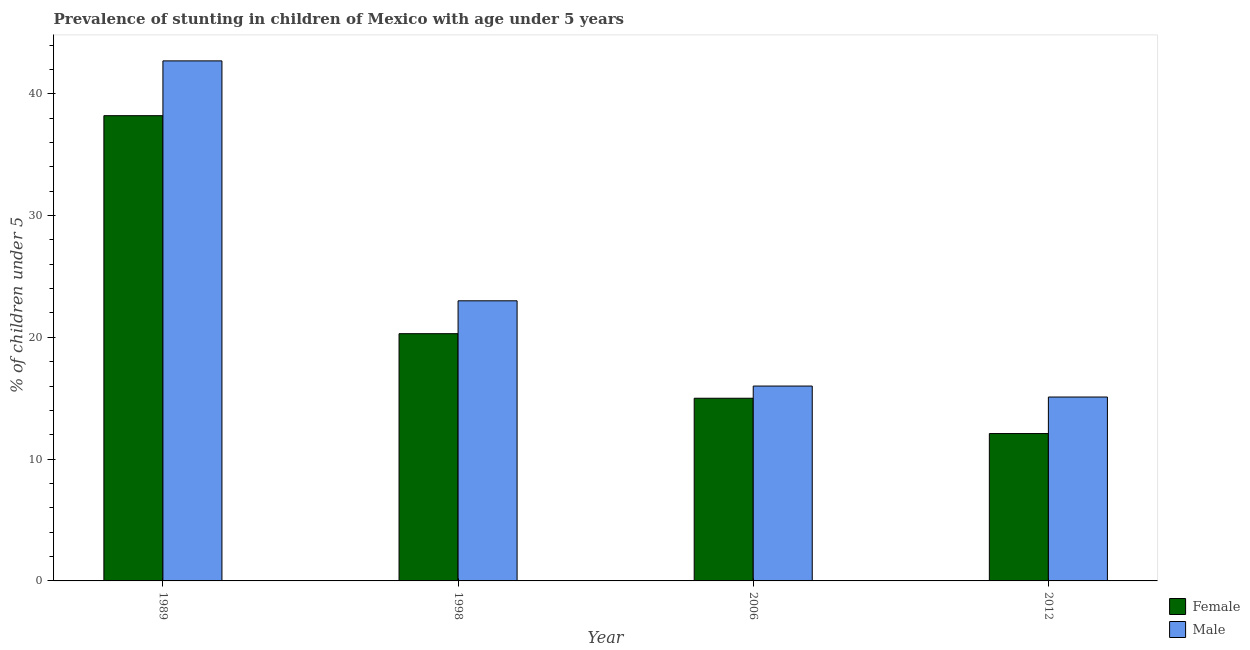How many different coloured bars are there?
Provide a short and direct response. 2. Are the number of bars per tick equal to the number of legend labels?
Keep it short and to the point. Yes. Are the number of bars on each tick of the X-axis equal?
Make the answer very short. Yes. What is the label of the 1st group of bars from the left?
Your answer should be compact. 1989. What is the percentage of stunted female children in 2006?
Give a very brief answer. 15. Across all years, what is the maximum percentage of stunted female children?
Provide a short and direct response. 38.2. Across all years, what is the minimum percentage of stunted male children?
Provide a succinct answer. 15.1. In which year was the percentage of stunted male children minimum?
Make the answer very short. 2012. What is the total percentage of stunted male children in the graph?
Make the answer very short. 96.8. What is the difference between the percentage of stunted male children in 1998 and that in 2012?
Offer a very short reply. 7.9. What is the difference between the percentage of stunted female children in 1989 and the percentage of stunted male children in 2012?
Your answer should be very brief. 26.1. What is the average percentage of stunted female children per year?
Offer a very short reply. 21.4. What is the ratio of the percentage of stunted male children in 1998 to that in 2012?
Provide a succinct answer. 1.52. Is the percentage of stunted female children in 2006 less than that in 2012?
Offer a very short reply. No. Is the difference between the percentage of stunted female children in 1989 and 1998 greater than the difference between the percentage of stunted male children in 1989 and 1998?
Your answer should be compact. No. What is the difference between the highest and the second highest percentage of stunted male children?
Ensure brevity in your answer.  19.7. What is the difference between the highest and the lowest percentage of stunted female children?
Ensure brevity in your answer.  26.1. What does the 2nd bar from the left in 1998 represents?
Offer a terse response. Male. Are all the bars in the graph horizontal?
Give a very brief answer. No. How many years are there in the graph?
Provide a succinct answer. 4. What is the difference between two consecutive major ticks on the Y-axis?
Your response must be concise. 10. Are the values on the major ticks of Y-axis written in scientific E-notation?
Offer a terse response. No. Does the graph contain grids?
Offer a terse response. No. Where does the legend appear in the graph?
Offer a terse response. Bottom right. What is the title of the graph?
Keep it short and to the point. Prevalence of stunting in children of Mexico with age under 5 years. What is the label or title of the Y-axis?
Keep it short and to the point.  % of children under 5. What is the  % of children under 5 of Female in 1989?
Make the answer very short. 38.2. What is the  % of children under 5 of Male in 1989?
Ensure brevity in your answer.  42.7. What is the  % of children under 5 in Female in 1998?
Your response must be concise. 20.3. What is the  % of children under 5 in Male in 1998?
Give a very brief answer. 23. What is the  % of children under 5 of Female in 2006?
Offer a very short reply. 15. What is the  % of children under 5 in Male in 2006?
Give a very brief answer. 16. What is the  % of children under 5 of Female in 2012?
Your answer should be very brief. 12.1. What is the  % of children under 5 of Male in 2012?
Provide a succinct answer. 15.1. Across all years, what is the maximum  % of children under 5 of Female?
Provide a short and direct response. 38.2. Across all years, what is the maximum  % of children under 5 of Male?
Make the answer very short. 42.7. Across all years, what is the minimum  % of children under 5 of Female?
Provide a short and direct response. 12.1. Across all years, what is the minimum  % of children under 5 in Male?
Give a very brief answer. 15.1. What is the total  % of children under 5 of Female in the graph?
Your response must be concise. 85.6. What is the total  % of children under 5 in Male in the graph?
Offer a very short reply. 96.8. What is the difference between the  % of children under 5 in Female in 1989 and that in 1998?
Ensure brevity in your answer.  17.9. What is the difference between the  % of children under 5 in Female in 1989 and that in 2006?
Provide a short and direct response. 23.2. What is the difference between the  % of children under 5 in Male in 1989 and that in 2006?
Provide a short and direct response. 26.7. What is the difference between the  % of children under 5 of Female in 1989 and that in 2012?
Your answer should be very brief. 26.1. What is the difference between the  % of children under 5 in Male in 1989 and that in 2012?
Offer a very short reply. 27.6. What is the difference between the  % of children under 5 of Female in 1998 and that in 2006?
Ensure brevity in your answer.  5.3. What is the difference between the  % of children under 5 of Male in 1998 and that in 2012?
Your response must be concise. 7.9. What is the difference between the  % of children under 5 in Female in 2006 and that in 2012?
Your answer should be very brief. 2.9. What is the difference between the  % of children under 5 of Male in 2006 and that in 2012?
Offer a very short reply. 0.9. What is the difference between the  % of children under 5 of Female in 1989 and the  % of children under 5 of Male in 1998?
Make the answer very short. 15.2. What is the difference between the  % of children under 5 in Female in 1989 and the  % of children under 5 in Male in 2006?
Provide a short and direct response. 22.2. What is the difference between the  % of children under 5 in Female in 1989 and the  % of children under 5 in Male in 2012?
Make the answer very short. 23.1. What is the difference between the  % of children under 5 in Female in 1998 and the  % of children under 5 in Male in 2012?
Make the answer very short. 5.2. What is the difference between the  % of children under 5 of Female in 2006 and the  % of children under 5 of Male in 2012?
Keep it short and to the point. -0.1. What is the average  % of children under 5 in Female per year?
Your answer should be compact. 21.4. What is the average  % of children under 5 of Male per year?
Your response must be concise. 24.2. In the year 1989, what is the difference between the  % of children under 5 in Female and  % of children under 5 in Male?
Offer a very short reply. -4.5. In the year 1998, what is the difference between the  % of children under 5 of Female and  % of children under 5 of Male?
Give a very brief answer. -2.7. In the year 2006, what is the difference between the  % of children under 5 of Female and  % of children under 5 of Male?
Make the answer very short. -1. In the year 2012, what is the difference between the  % of children under 5 in Female and  % of children under 5 in Male?
Your response must be concise. -3. What is the ratio of the  % of children under 5 in Female in 1989 to that in 1998?
Provide a short and direct response. 1.88. What is the ratio of the  % of children under 5 in Male in 1989 to that in 1998?
Your response must be concise. 1.86. What is the ratio of the  % of children under 5 in Female in 1989 to that in 2006?
Keep it short and to the point. 2.55. What is the ratio of the  % of children under 5 of Male in 1989 to that in 2006?
Your answer should be compact. 2.67. What is the ratio of the  % of children under 5 in Female in 1989 to that in 2012?
Provide a succinct answer. 3.16. What is the ratio of the  % of children under 5 in Male in 1989 to that in 2012?
Keep it short and to the point. 2.83. What is the ratio of the  % of children under 5 in Female in 1998 to that in 2006?
Your answer should be compact. 1.35. What is the ratio of the  % of children under 5 of Male in 1998 to that in 2006?
Give a very brief answer. 1.44. What is the ratio of the  % of children under 5 in Female in 1998 to that in 2012?
Offer a terse response. 1.68. What is the ratio of the  % of children under 5 of Male in 1998 to that in 2012?
Your answer should be compact. 1.52. What is the ratio of the  % of children under 5 of Female in 2006 to that in 2012?
Give a very brief answer. 1.24. What is the ratio of the  % of children under 5 of Male in 2006 to that in 2012?
Provide a short and direct response. 1.06. What is the difference between the highest and the second highest  % of children under 5 of Male?
Your response must be concise. 19.7. What is the difference between the highest and the lowest  % of children under 5 in Female?
Provide a short and direct response. 26.1. What is the difference between the highest and the lowest  % of children under 5 of Male?
Offer a terse response. 27.6. 